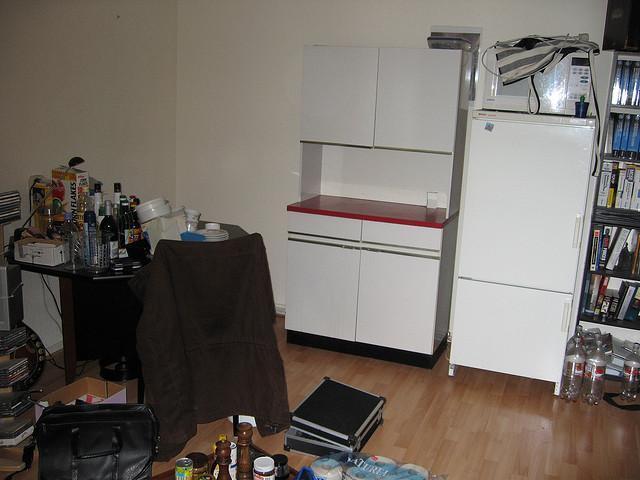How many pieces of luggage are red?
Give a very brief answer. 0. How many chairs are there?
Give a very brief answer. 1. How many books are there?
Give a very brief answer. 1. How many chairs are visible?
Give a very brief answer. 1. How many suitcases are in the photo?
Give a very brief answer. 2. 